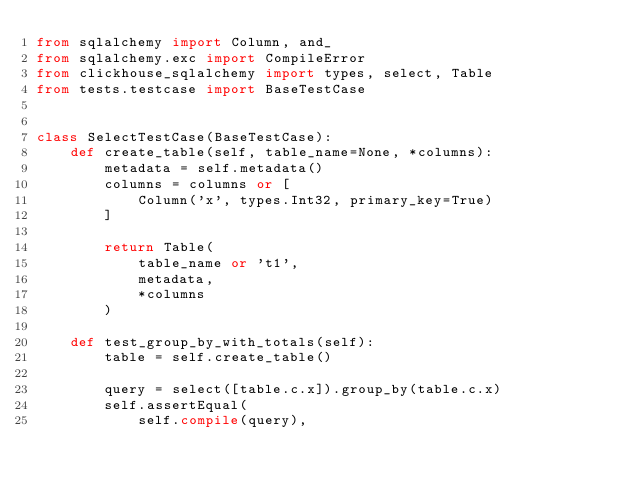Convert code to text. <code><loc_0><loc_0><loc_500><loc_500><_Python_>from sqlalchemy import Column, and_
from sqlalchemy.exc import CompileError
from clickhouse_sqlalchemy import types, select, Table
from tests.testcase import BaseTestCase


class SelectTestCase(BaseTestCase):
    def create_table(self, table_name=None, *columns):
        metadata = self.metadata()
        columns = columns or [
            Column('x', types.Int32, primary_key=True)
        ]

        return Table(
            table_name or 't1',
            metadata,
            *columns
        )

    def test_group_by_with_totals(self):
        table = self.create_table()

        query = select([table.c.x]).group_by(table.c.x)
        self.assertEqual(
            self.compile(query),</code> 